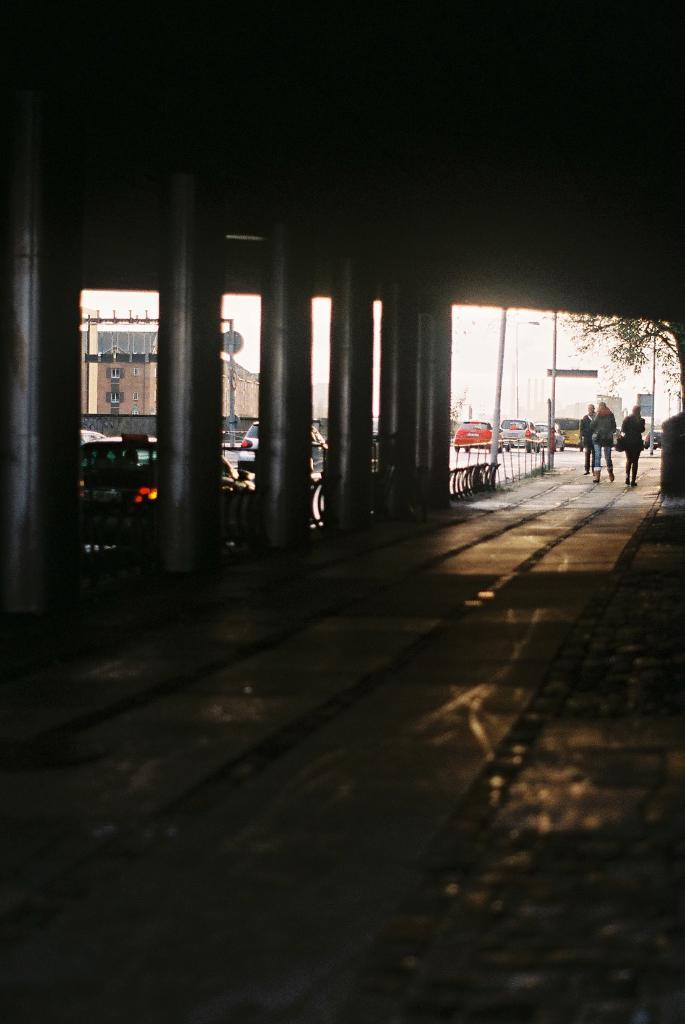Please provide a concise description of this image. This picture is an inside view of a shed. In this picture we can see the pillars, barricades, poles, vehicles, building, windows, boards, trees, some persons and sky. At the top of the image we can see the roof. At the bottom of the image we can see the floor. 